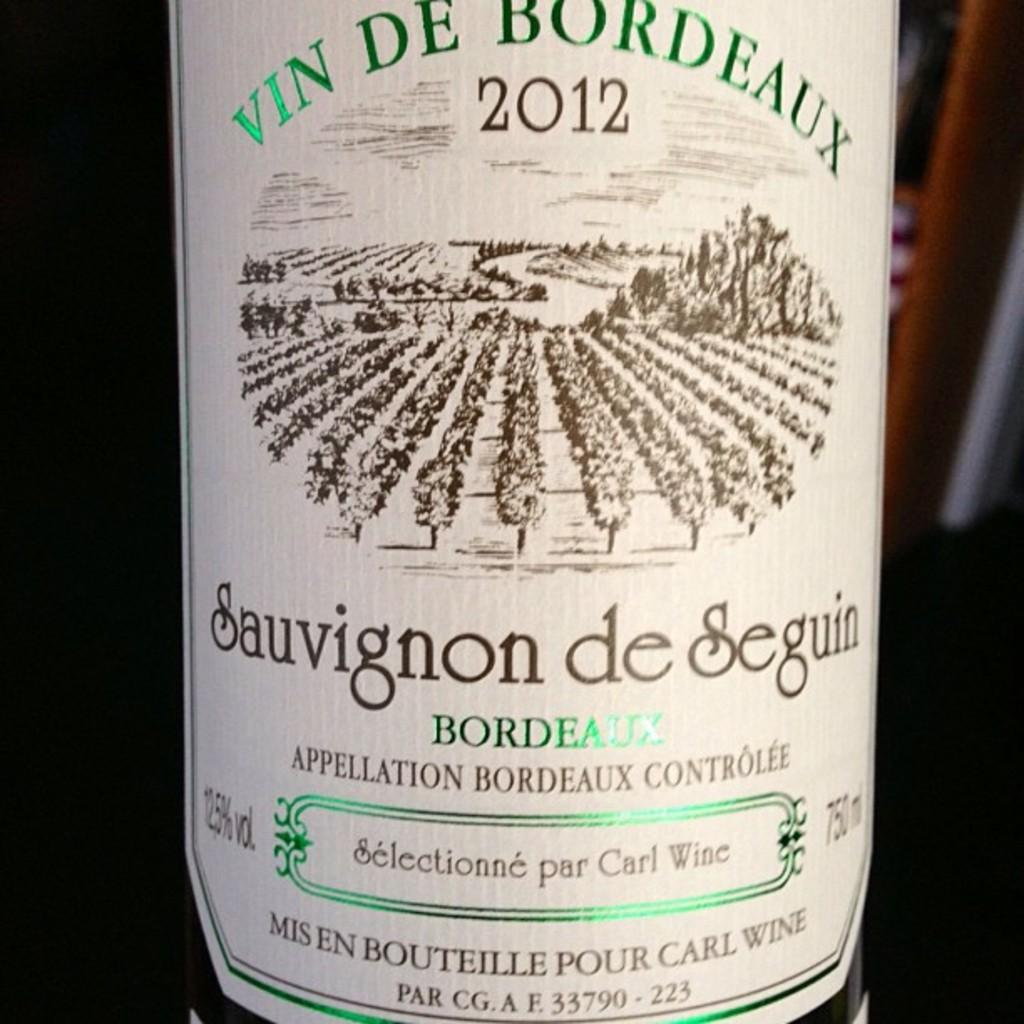<image>
Share a concise interpretation of the image provided. the year 2012 that is on a bottle 